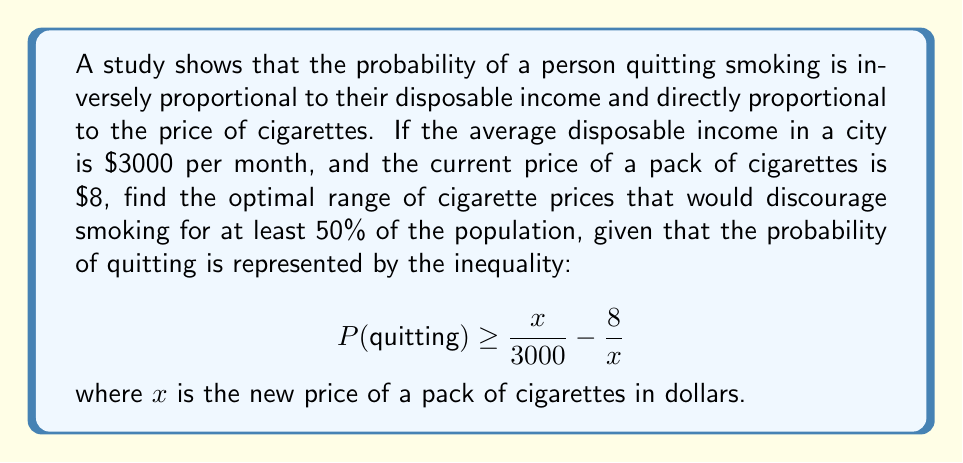Could you help me with this problem? To find the optimal range of cigarette prices, we need to solve the inequality:

$$ \frac{x}{3000} - \frac{8}{x} \geq 0.5 $$

Step 1: Multiply both sides by $x$:
$$ \frac{x^2}{3000} - 8 \geq 0.5x $$

Step 2: Multiply all terms by 3000:
$$ x^2 - 24000 \geq 1500x $$

Step 3: Rearrange to standard quadratic form:
$$ x^2 - 1500x - 24000 \leq 0 $$

Step 4: Solve the quadratic inequality using the quadratic formula:
$$ x = \frac{-b \pm \sqrt{b^2 - 4ac}}{2a} $$
where $a=1$, $b=-1500$, and $c=-24000$

$$ x = \frac{1500 \pm \sqrt{1500^2 - 4(1)(-24000)}}{2(1)} $$
$$ x = \frac{1500 \pm \sqrt{2250000 + 96000}}{2} $$
$$ x = \frac{1500 \pm \sqrt{2346000}}{2} $$
$$ x = \frac{1500 \pm 1531.67}{2} $$

Step 5: Solve for the two roots:
$$ x_1 = \frac{1500 + 1531.67}{2} \approx 1515.84 $$
$$ x_2 = \frac{1500 - 1531.67}{2} \approx -15.84 $$

Step 6: Since prices can't be negative, we only consider the positive root. The optimal range is from the current price ($8) to the positive root ($1515.84).

Therefore, the optimal range of cigarette prices to discourage smoking for at least 50% of the population is $8 \leq x \leq 1515.84$.
Answer: $[8, 1515.84]$ 